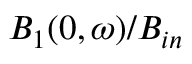Convert formula to latex. <formula><loc_0><loc_0><loc_500><loc_500>B _ { 1 } ( 0 , \omega ) / B _ { i n }</formula> 